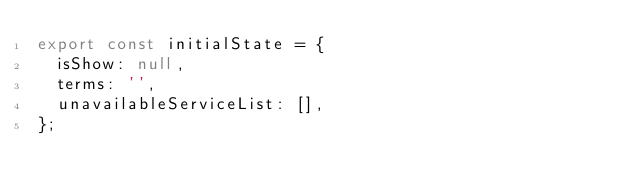<code> <loc_0><loc_0><loc_500><loc_500><_JavaScript_>export const initialState = {
  isShow: null,
  terms: '',
  unavailableServiceList: [],
};
</code> 